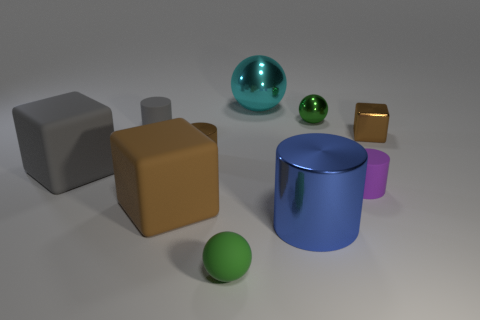Are there any matte objects of the same shape as the cyan metallic object?
Your answer should be compact. Yes. What is the shape of the gray matte thing that is the same size as the green matte sphere?
Give a very brief answer. Cylinder. How many large things have the same color as the small block?
Provide a short and direct response. 1. There is a rubber object that is behind the tiny brown cylinder; what size is it?
Give a very brief answer. Small. What number of green spheres have the same size as the brown rubber block?
Your response must be concise. 0. The cylinder that is made of the same material as the purple thing is what color?
Provide a short and direct response. Gray. Are there fewer small matte things that are behind the large gray rubber cube than large things?
Make the answer very short. Yes. What shape is the big blue object that is the same material as the big cyan ball?
Make the answer very short. Cylinder. How many metallic things are cyan things or small green objects?
Your answer should be very brief. 2. Is the number of big blue metal cylinders to the left of the gray matte block the same as the number of brown spheres?
Make the answer very short. Yes. 